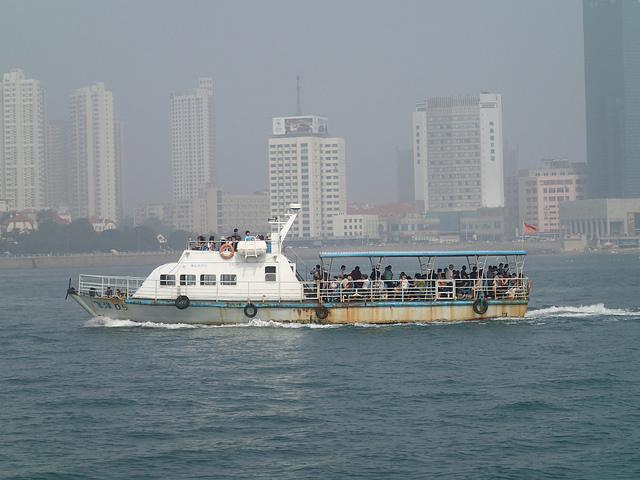Where are the people on the boat ultimately headed? Please explain your reasoning. near shore. The boat is transporting people to a shore near the city. 